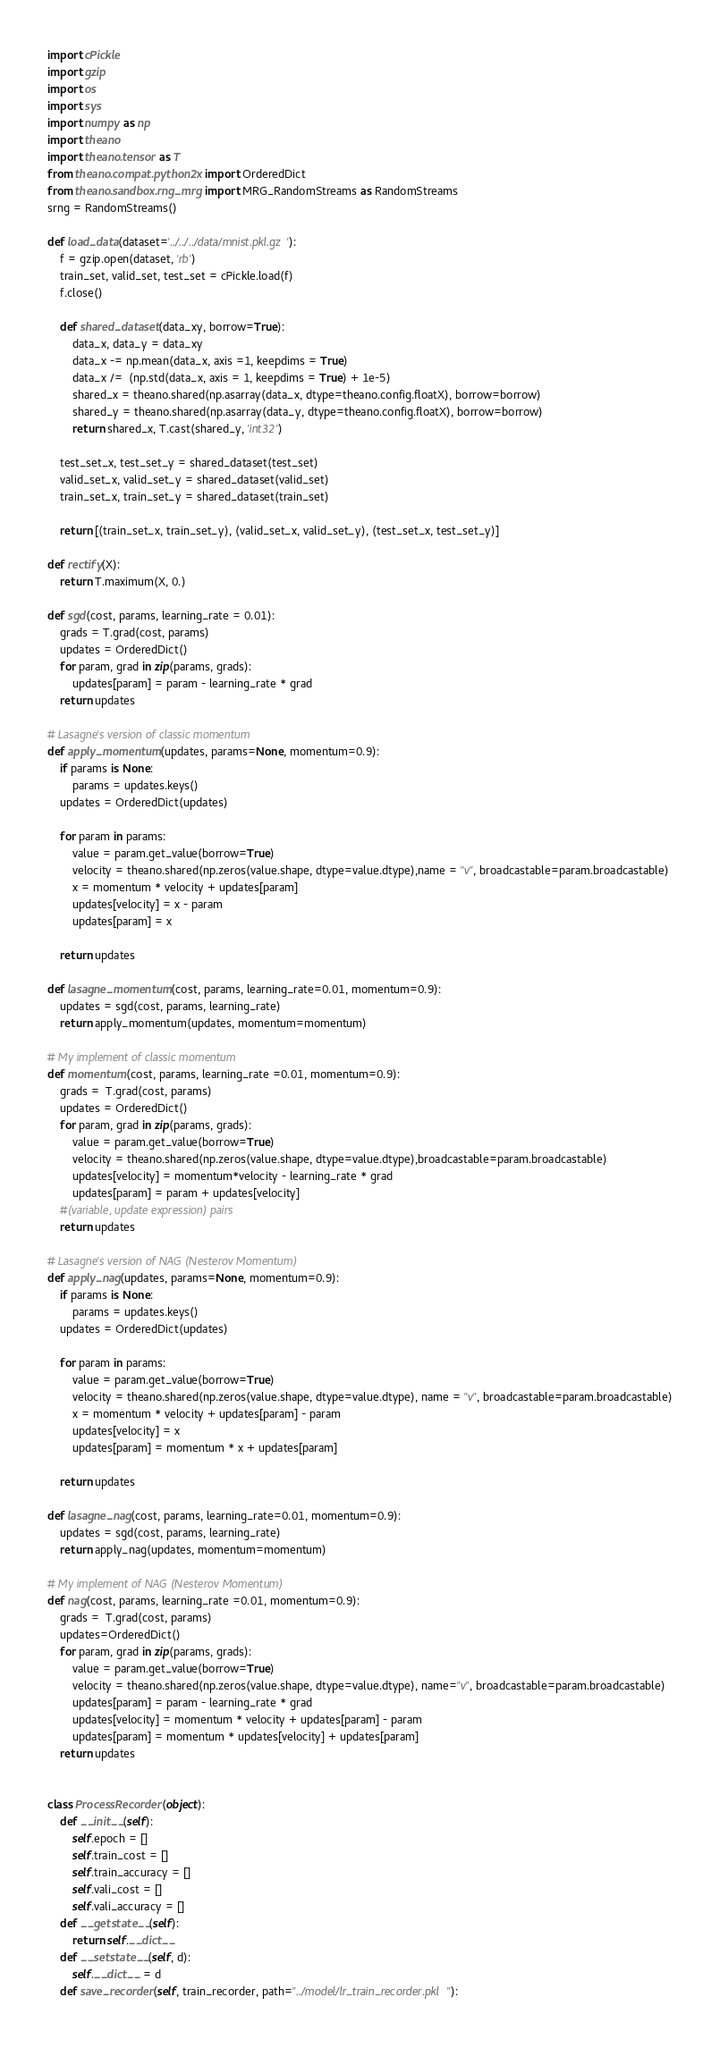Convert code to text. <code><loc_0><loc_0><loc_500><loc_500><_Python_>import cPickle
import gzip
import os
import sys
import numpy as np
import theano
import theano.tensor as T
from theano.compat.python2x import OrderedDict
from theano.sandbox.rng_mrg import MRG_RandomStreams as RandomStreams
srng = RandomStreams()

def load_data(dataset='../../../data/mnist.pkl.gz'):
    f = gzip.open(dataset, 'rb')
    train_set, valid_set, test_set = cPickle.load(f)
    f.close()

    def shared_dataset(data_xy, borrow=True):
        data_x, data_y = data_xy
        data_x -= np.mean(data_x, axis =1, keepdims = True)
        data_x /=  (np.std(data_x, axis = 1, keepdims = True) + 1e-5)
        shared_x = theano.shared(np.asarray(data_x, dtype=theano.config.floatX), borrow=borrow)
        shared_y = theano.shared(np.asarray(data_y, dtype=theano.config.floatX), borrow=borrow)
        return shared_x, T.cast(shared_y, 'int32')

    test_set_x, test_set_y = shared_dataset(test_set)
    valid_set_x, valid_set_y = shared_dataset(valid_set)
    train_set_x, train_set_y = shared_dataset(train_set)

    return [(train_set_x, train_set_y), (valid_set_x, valid_set_y), (test_set_x, test_set_y)]

def rectify(X):
    return T.maximum(X, 0.)

def sgd(cost, params, learning_rate = 0.01):
    grads = T.grad(cost, params)
    updates = OrderedDict()
    for param, grad in zip(params, grads):
        updates[param] = param - learning_rate * grad
    return updates

# Lasagne's version of classic momentum
def apply_momentum(updates, params=None, momentum=0.9):
    if params is None:
        params = updates.keys()
    updates = OrderedDict(updates)

    for param in params:
        value = param.get_value(borrow=True)
        velocity = theano.shared(np.zeros(value.shape, dtype=value.dtype),name = "v", broadcastable=param.broadcastable)
        x = momentum * velocity + updates[param]
        updates[velocity] = x - param
        updates[param] = x

    return updates

def lasagne_momentum(cost, params, learning_rate=0.01, momentum=0.9):
    updates = sgd(cost, params, learning_rate)
    return apply_momentum(updates, momentum=momentum)

# My implement of classic momentum
def momentum(cost, params, learning_rate =0.01, momentum=0.9):
    grads =  T.grad(cost, params)
    updates = OrderedDict()
    for param, grad in zip(params, grads):
        value = param.get_value(borrow=True)
        velocity = theano.shared(np.zeros(value.shape, dtype=value.dtype),broadcastable=param.broadcastable)
        updates[velocity] = momentum*velocity - learning_rate * grad
        updates[param] = param + updates[velocity]
    #(variable, update expression) pairs
    return updates

# Lasagne's version of NAG (Nesterov Momentum)
def apply_nag(updates, params=None, momentum=0.9):
    if params is None:
        params = updates.keys()
    updates = OrderedDict(updates)

    for param in params:
        value = param.get_value(borrow=True)
        velocity = theano.shared(np.zeros(value.shape, dtype=value.dtype), name = "v", broadcastable=param.broadcastable)
        x = momentum * velocity + updates[param] - param
        updates[velocity] = x
        updates[param] = momentum * x + updates[param]

    return updates

def lasagne_nag(cost, params, learning_rate=0.01, momentum=0.9):
    updates = sgd(cost, params, learning_rate)
    return apply_nag(updates, momentum=momentum)

# My implement of NAG (Nesterov Momentum)
def nag(cost, params, learning_rate =0.01, momentum=0.9):
    grads =  T.grad(cost, params)
    updates=OrderedDict()
    for param, grad in zip(params, grads):
        value = param.get_value(borrow=True)
        velocity = theano.shared(np.zeros(value.shape, dtype=value.dtype), name="v", broadcastable=param.broadcastable)
        updates[param] = param - learning_rate * grad
        updates[velocity] = momentum * velocity + updates[param] - param
        updates[param] = momentum * updates[velocity] + updates[param]
    return updates


class ProcessRecorder(object):
    def __init__(self):
        self.epoch = []
        self.train_cost = []
        self.train_accuracy = []
        self.vali_cost = []
        self.vali_accuracy = []
    def __getstate__(self):
        return self.__dict__
    def __setstate__(self, d):
        self.__dict__ = d
    def save_recorder(self, train_recorder, path="../model/lr_train_recorder.pkl"):</code> 